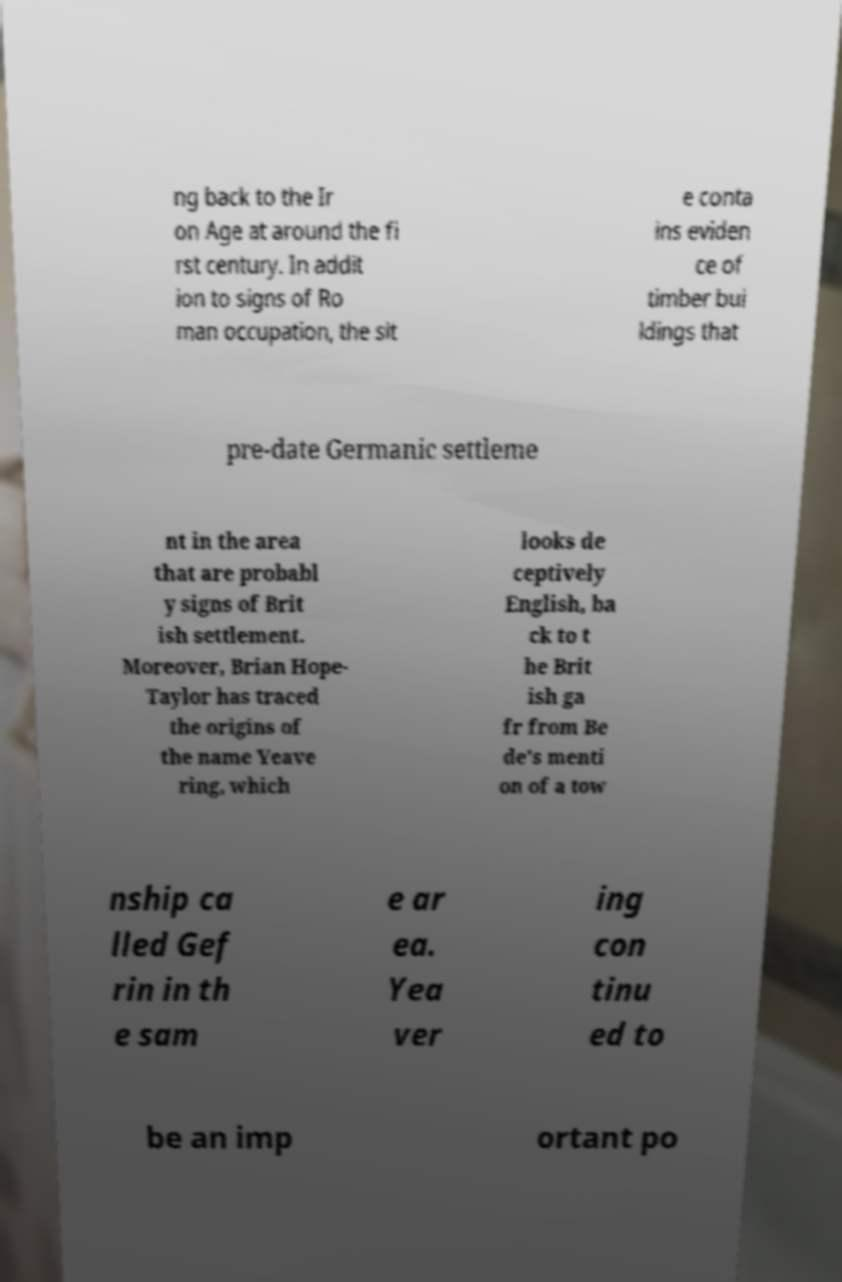Could you extract and type out the text from this image? ng back to the Ir on Age at around the fi rst century. In addit ion to signs of Ro man occupation, the sit e conta ins eviden ce of timber bui ldings that pre-date Germanic settleme nt in the area that are probabl y signs of Brit ish settlement. Moreover, Brian Hope- Taylor has traced the origins of the name Yeave ring, which looks de ceptively English, ba ck to t he Brit ish ga fr from Be de's menti on of a tow nship ca lled Gef rin in th e sam e ar ea. Yea ver ing con tinu ed to be an imp ortant po 